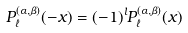<formula> <loc_0><loc_0><loc_500><loc_500>P _ { \ell } ^ { ( \alpha , \beta ) } ( - x ) = ( - 1 ) ^ { l } P _ { \ell } ^ { ( \alpha , \beta ) } ( x )</formula> 